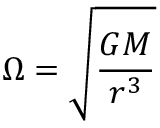Convert formula to latex. <formula><loc_0><loc_0><loc_500><loc_500>\Omega = { \sqrt { \frac { G M } { r ^ { 3 } } } }</formula> 